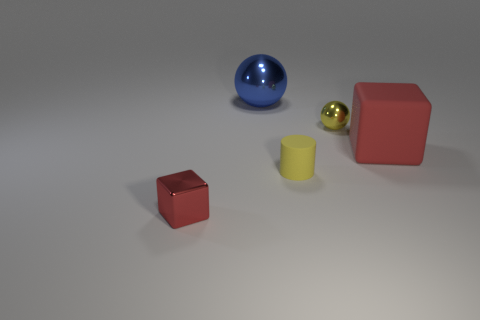Add 5 tiny shiny balls. How many objects exist? 10 Subtract all cylinders. How many objects are left? 4 Subtract 0 gray spheres. How many objects are left? 5 Subtract all tiny red metallic things. Subtract all tiny yellow rubber cylinders. How many objects are left? 3 Add 3 balls. How many balls are left? 5 Add 4 brown objects. How many brown objects exist? 4 